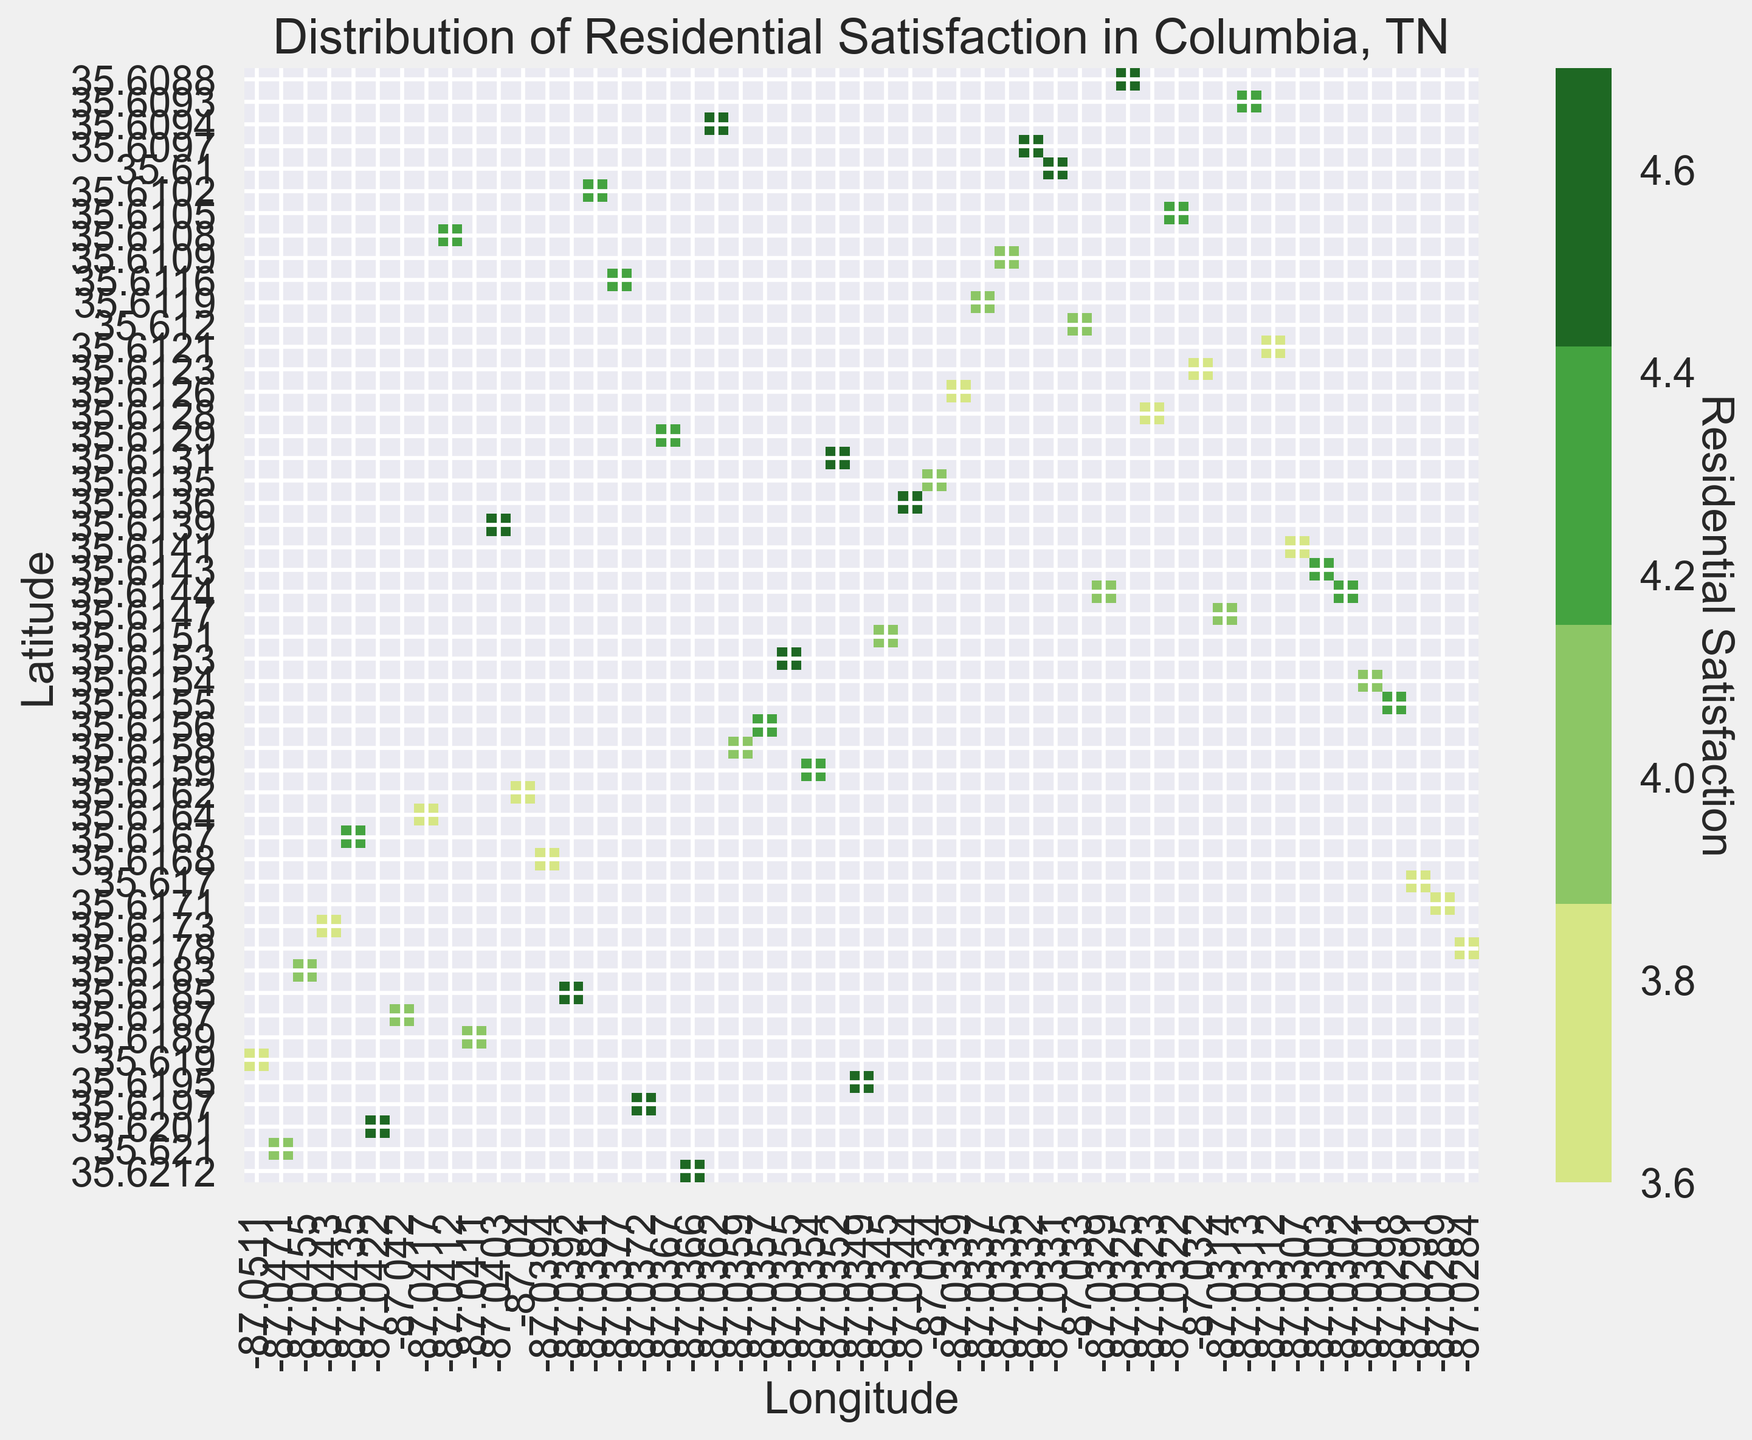Which area has the highest average residential satisfaction? Look for the darkest green areas in the heatmap, as these represent the highest residential satisfaction scores.
Answer: The area around (35.6185, -87.0392) Which area has the lowest residential satisfaction for public transportation? Identify the coordinates where public transportation satisfaction is the lightest green (indicative of lower satisfaction) on the heatmap.
Answer: Around coordinates (35.6167, -87.0435) Is there a noticeable difference in residential satisfaction between areas closer to parks and areas closer to grocery stores? Compare the shades of green near parks and grocery stores. Darker green indicates higher satisfaction while lighter green indicates lower satisfaction.
Answer: Generally, areas closer to parks have slightly higher residential satisfaction Comparing the satisfaction levels, do people seem more satisfied living near grocery stores or public transportation? Look at the shades of green around grocery stores and public transportation sites. The darker the green, the higher the satisfaction.
Answer: Grocery stores Which location has a residential satisfaction rating of approximately 4.7? Search for the darkest green squares indicating a score of around 4.7, then identify the corresponding coordinates.
Answer: Coordinates around (35.6185, -87.0392) How does the satisfaction level change as you move from east to west across the map? Observe the gradient of green shades as you move horizontally across the map; note if it gets darker, lighter, or stays consistent.
Answer: There is no obvious east-to-west trend Are there any areas where all three amenities (parks, grocery stores, public transportation) are clustered together? Identify clusters where symbols representing parks, grocery stores, and public transportation are present in close proximity on the map.
Answer: No clear cluster of all three amenities Comparing two locations with coordinates (35.6139, -87.0403) and (35.6097, -87.0332), which one has higher residential satisfaction? Check the color intensity for these two specific coordinates; the darker the green, the higher the satisfaction.
Answer: (35.6139, -87.0403) 